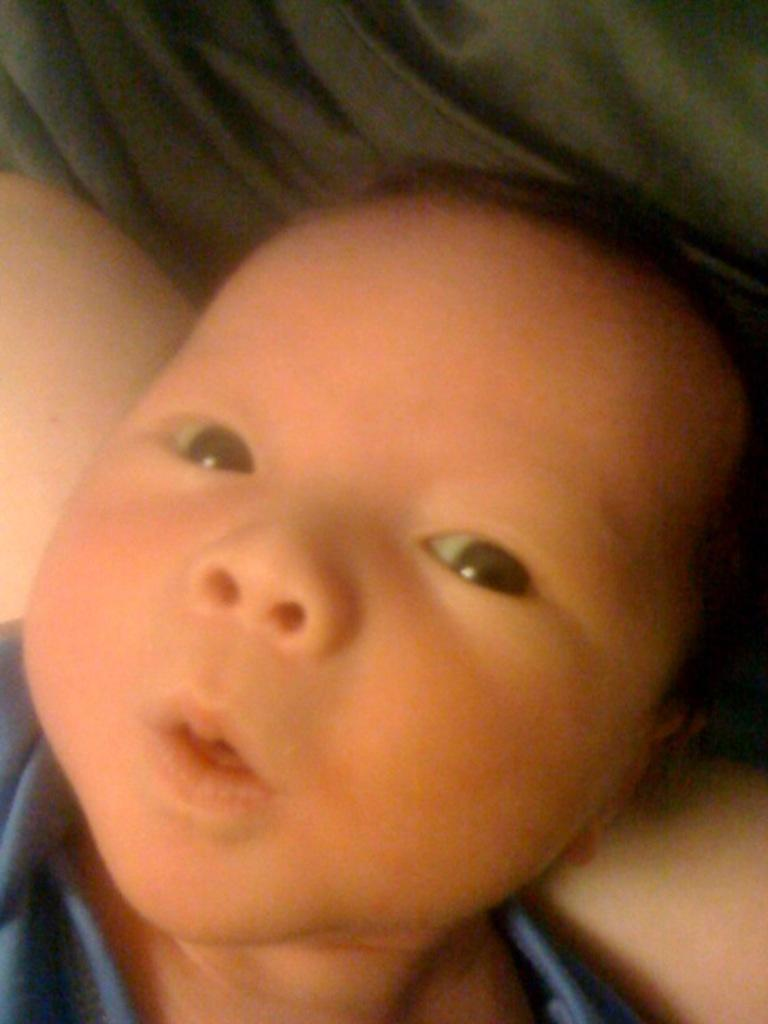What is the main subject of the image? There is a kid in the image. What is the kid wearing? The kid is wearing a blue T-shirt. Can you describe the person in the background of the image? The person in the background is wearing a green dress. What type of weather can be seen in the image? There is no information about the weather in the image. What part of the person in the background is visible in the image? The person in the background is not partially visible; the entire person is visible, wearing a green dress. 